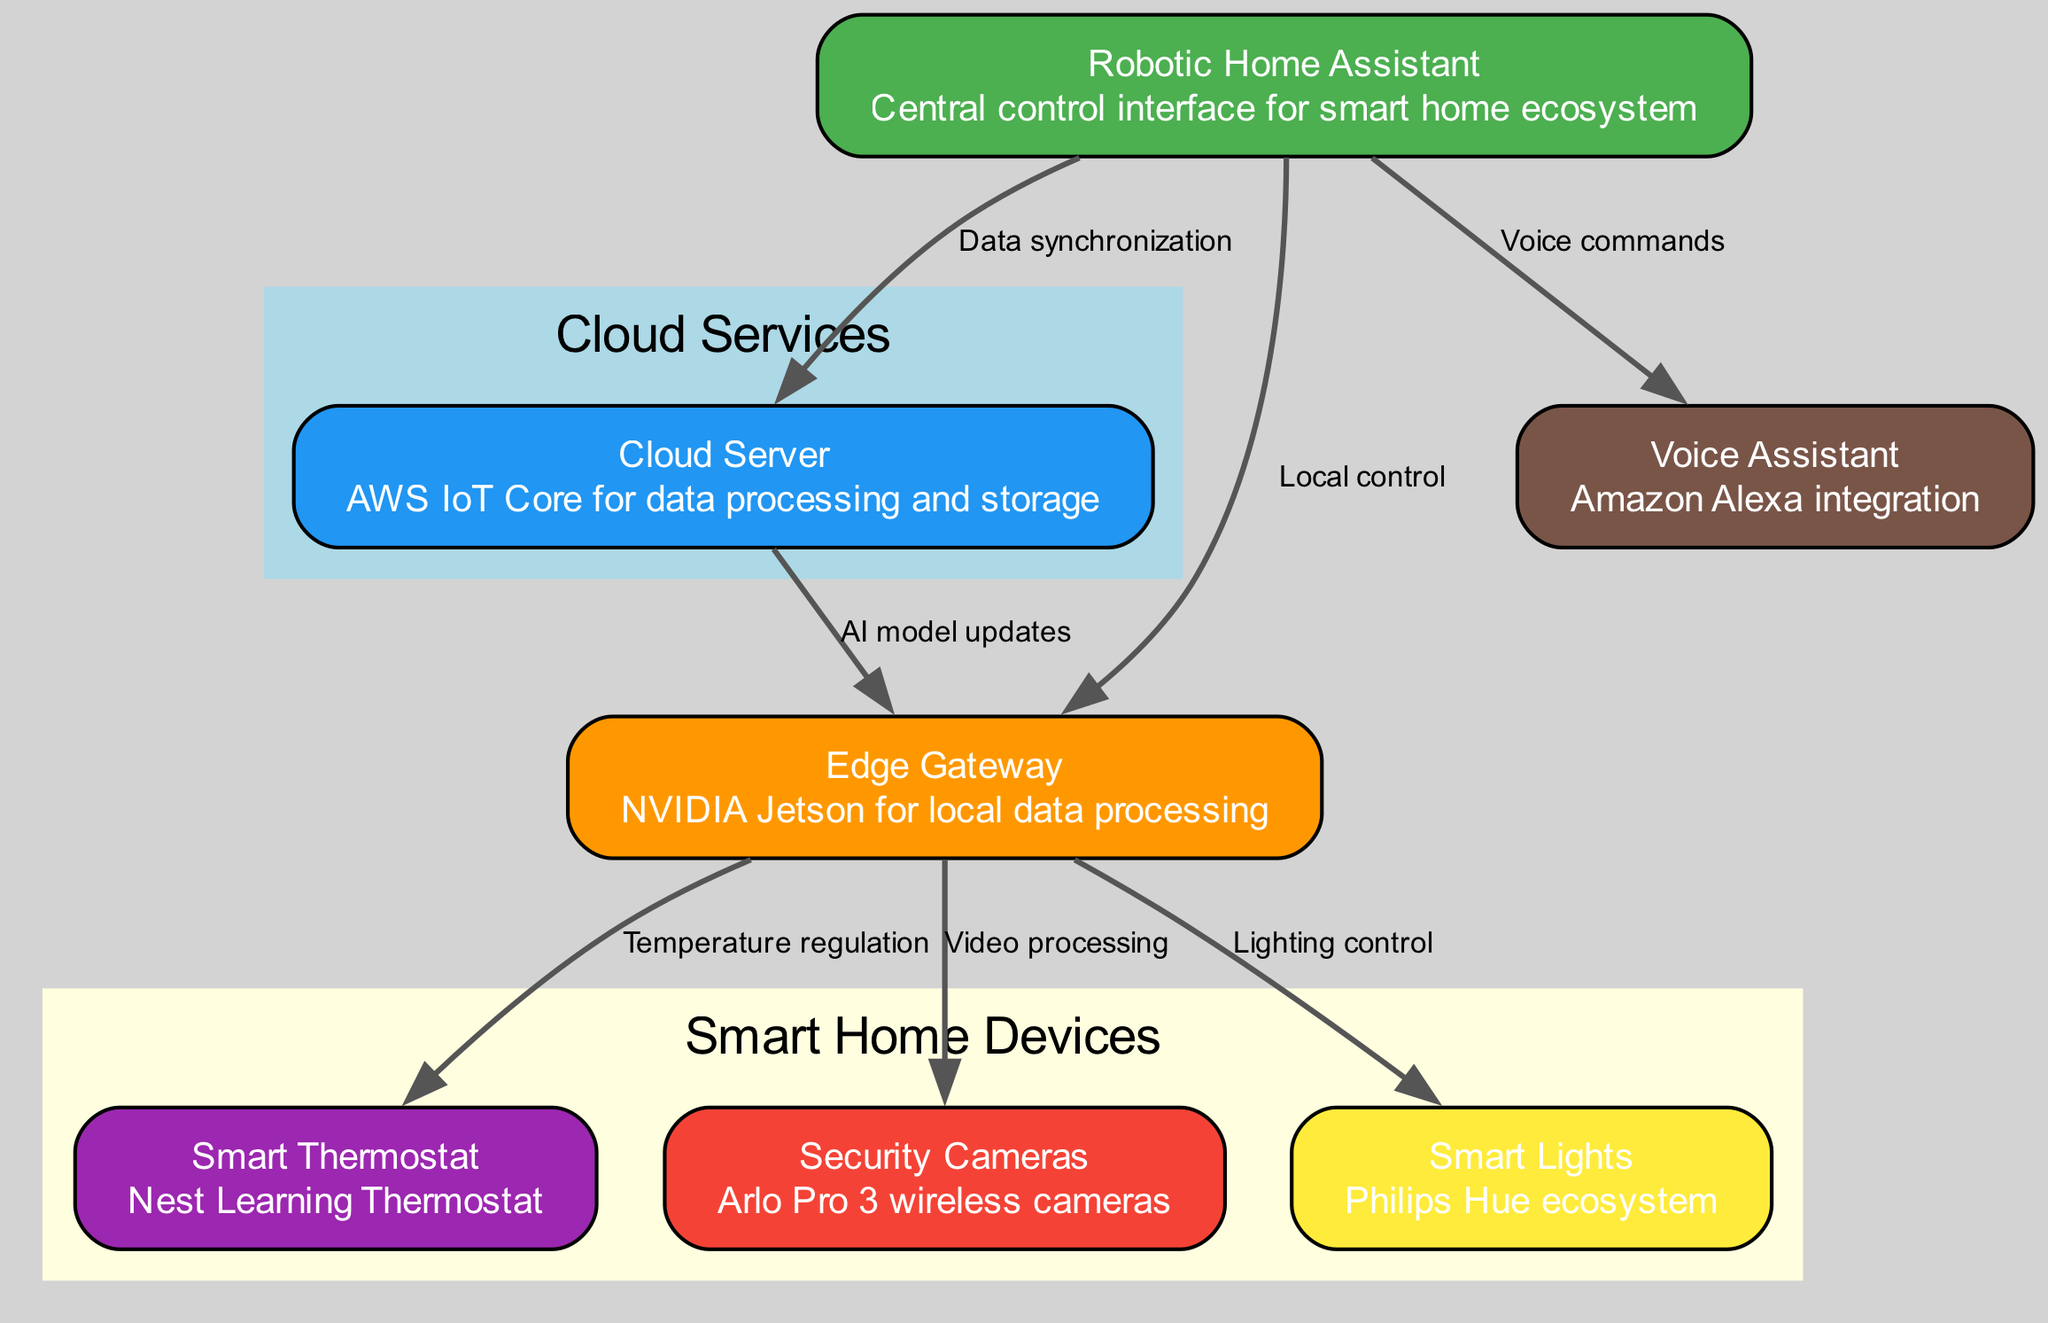What is the central control interface for the smart home ecosystem? The diagram identifies the "Robotic Home Assistant" as the central control interface. This node is clearly labeled at the top of the graph, setting the context for the entire ecosystem.
Answer: Robotic Home Assistant How many devices are shown as part of the smart home devices group? In the diagram, the smart home devices group includes three nodes: Smart Thermostat, Security Cameras, and Smart Lights. These nodes are encapsulated within the yellow subgraph, clearly indicating their categorization.
Answer: 3 What type of data synchronization occurs between the Robotic Home Assistant and the Cloud Server? The diagram indicates that "Data synchronization" is the relationship between the Robotic Home Assistant and the Cloud Server. This is denoted by an edge labeled accordingly, linking the two nodes.
Answer: Data synchronization What is the role of the Edge Gateway in this ecosystem? The Edge Gateway's role is defined by multiple edges leading to smart home devices; it is responsible for "Local data processing." The connections indicate its function in managing control over devices such as the Smart Thermostat, Security Cameras, and Smart Lights.
Answer: Local data processing Which device is connected for video processing via the Edge Gateway? The diagram shows a direct edge from the Edge Gateway to the Security Cameras with the label "Video processing," indicating that this specific device is linked for handling video data processing.
Answer: Security Cameras What command system interacts with the Robotic Home Assistant? The diagram specifies that "Voice commands" are used as the command system, as indicated by the edge connecting from the Robotic Home Assistant to the Voice Assistant node in the diagram.
Answer: Voice commands Which component receives AI model updates from the Cloud Server? The edge labeled "AI model updates" connects the Cloud Server and the Edge Gateway, indicating that the Edge Gateway receives these updates, thus playing a crucial role in integrating AI into local processing.
Answer: Edge Gateway What kind of external interaction does the Robotic Home Assistant facilitate? The Robotic Home Assistant facilitates "Voice commands" sent through the Voice Assistant, showing an interactive layer that allows users to control the system via voice. This interaction is highlighted by the connecting edge between these two components.
Answer: Voice commands How does the Edge Gateway interact with the Smart Lights? The diagram presents an edge from the Edge Gateway to the Smart Lights labeled "Lighting control," which indicates the Edge Gateway's role in managing smart lighting settings integrated into the ecosystem.
Answer: Lighting control 